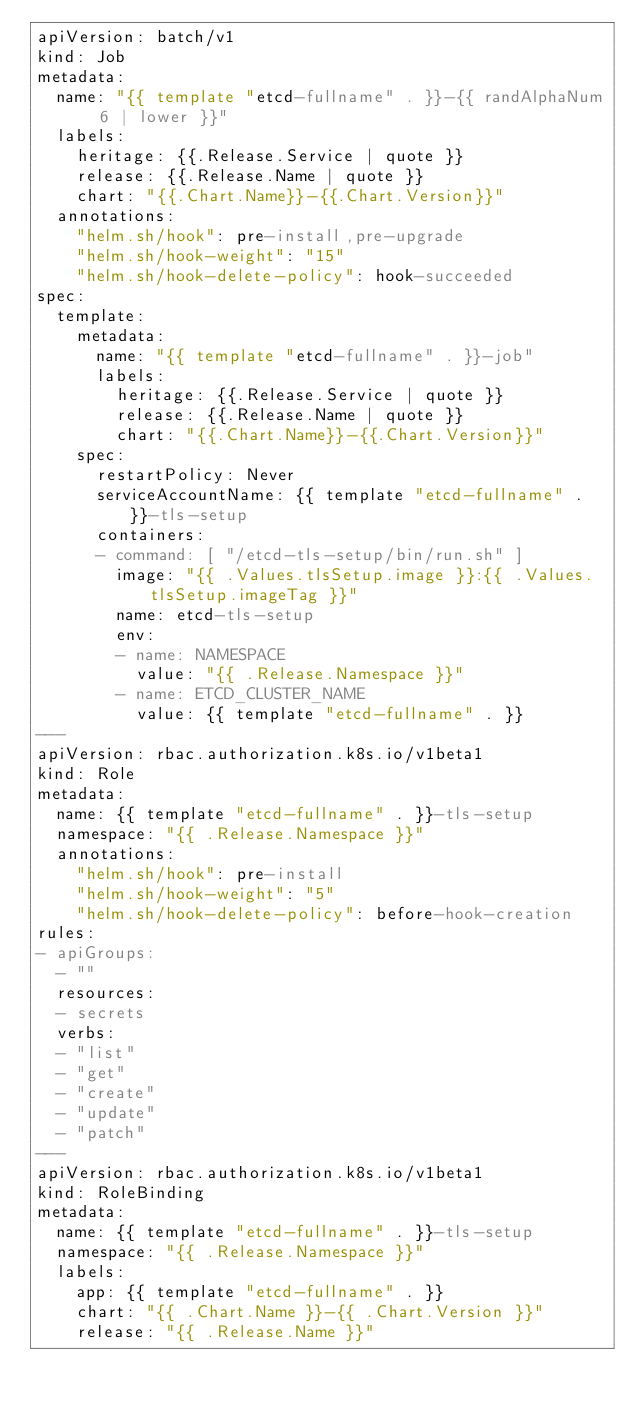Convert code to text. <code><loc_0><loc_0><loc_500><loc_500><_YAML_>apiVersion: batch/v1
kind: Job
metadata:
  name: "{{ template "etcd-fullname" . }}-{{ randAlphaNum 6 | lower }}"
  labels:
    heritage: {{.Release.Service | quote }}
    release: {{.Release.Name | quote }}
    chart: "{{.Chart.Name}}-{{.Chart.Version}}"
  annotations:
    "helm.sh/hook": pre-install,pre-upgrade
    "helm.sh/hook-weight": "15"
    "helm.sh/hook-delete-policy": hook-succeeded
spec:
  template:
    metadata:
      name: "{{ template "etcd-fullname" . }}-job"
      labels:
        heritage: {{.Release.Service | quote }}
        release: {{.Release.Name | quote }}
        chart: "{{.Chart.Name}}-{{.Chart.Version}}"
    spec:
      restartPolicy: Never
      serviceAccountName: {{ template "etcd-fullname" . }}-tls-setup
      containers:
      - command: [ "/etcd-tls-setup/bin/run.sh" ]
        image: "{{ .Values.tlsSetup.image }}:{{ .Values.tlsSetup.imageTag }}"
        name: etcd-tls-setup
        env:
        - name: NAMESPACE
          value: "{{ .Release.Namespace }}"
        - name: ETCD_CLUSTER_NAME
          value: {{ template "etcd-fullname" . }}
---
apiVersion: rbac.authorization.k8s.io/v1beta1
kind: Role
metadata:
  name: {{ template "etcd-fullname" . }}-tls-setup
  namespace: "{{ .Release.Namespace }}"
  annotations:
    "helm.sh/hook": pre-install
    "helm.sh/hook-weight": "5"
    "helm.sh/hook-delete-policy": before-hook-creation
rules:
- apiGroups:
  - ""
  resources:
  - secrets
  verbs:
  - "list"
  - "get"
  - "create"
  - "update"
  - "patch"
---
apiVersion: rbac.authorization.k8s.io/v1beta1
kind: RoleBinding
metadata:
  name: {{ template "etcd-fullname" . }}-tls-setup
  namespace: "{{ .Release.Namespace }}"
  labels:
    app: {{ template "etcd-fullname" . }}
    chart: "{{ .Chart.Name }}-{{ .Chart.Version }}"
    release: "{{ .Release.Name }}"</code> 